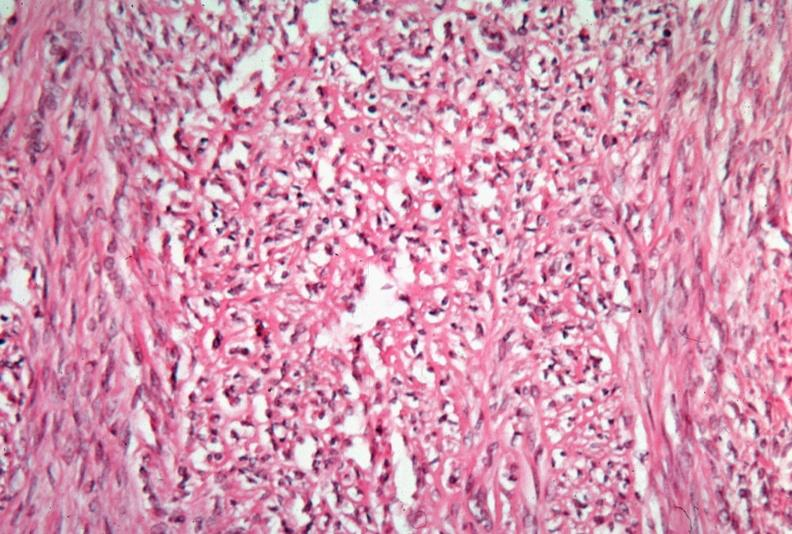s female reproductive present?
Answer the question using a single word or phrase. Yes 